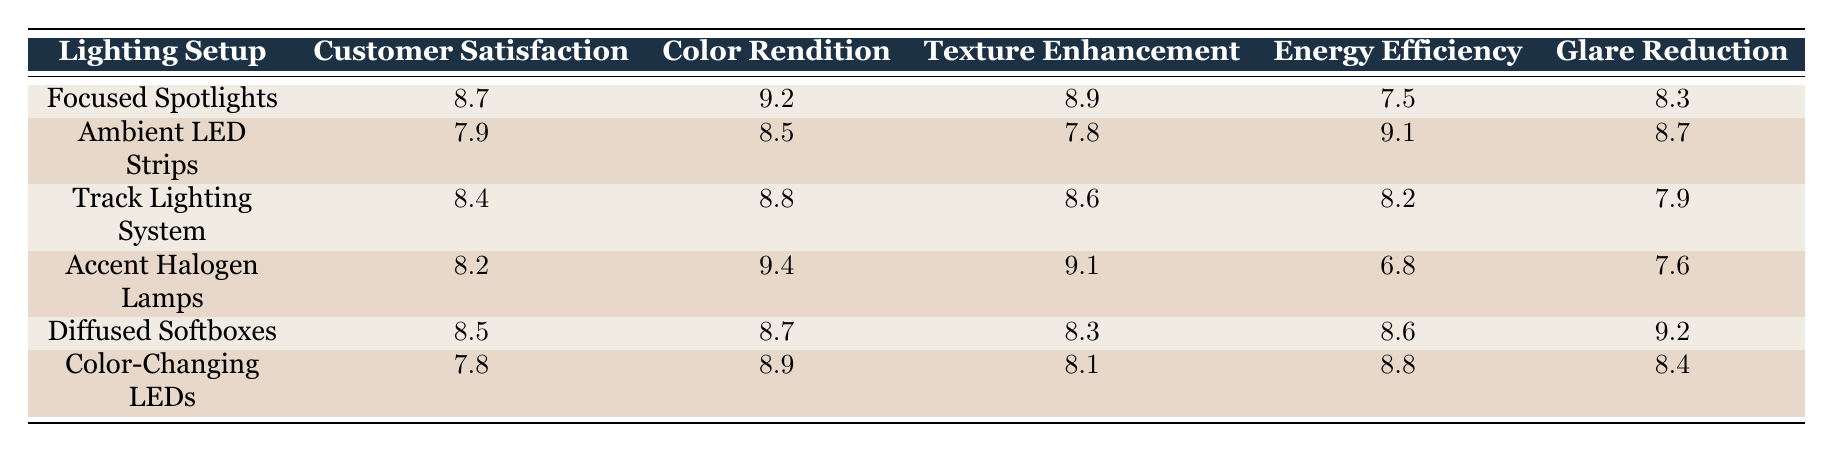What is the customer satisfaction rating for Focused Spotlights? The customer satisfaction rating for Focused Spotlights is listed directly in the table under the customer satisfaction column, which shows a value of 8.7.
Answer: 8.7 Which lighting setup has the highest color rendition score? The table indicates that Accent Halogen Lamps has the highest color rendition score of 9.4, which is the maximum value listed in that column.
Answer: Accent Halogen Lamps What is the average customer satisfaction rating for all the lighting setups? To find the average, we sum the customer satisfaction ratings: (8.7 + 7.9 + 8.4 + 8.2 + 8.5 + 7.8) = 49.5. Then we divide by the number of setups, which is 6. Thus, 49.5/6 = 8.25.
Answer: 8.25 Is the energy efficiency of Diffused Softboxes higher than that of Accent Halogen Lamps? By comparing the energy efficiency values in the table, we see that Diffused Softboxes has a score of 8.6 while Accent Halogen Lamps has a score of 6.8. Since 8.6 is greater than 6.8, the statement is true.
Answer: Yes Which lighting setup has the best glare reduction score, and what is that score? The glare reduction scores are compared from the table, and it is clear that Diffused Softboxes has the highest glare reduction score of 9.2.
Answer: Diffused Softboxes, 9.2 What is the difference in texture enhancement scores between Focused Spotlights and Color-Changing LEDs? The texture enhancement for Focused Spotlights is 8.9 and for Color-Changing LEDs is 8.1. The difference is calculated by subtracting: 8.9 - 8.1 = 0.8.
Answer: 0.8 Do Ambient LED Strips have a higher customer satisfaction rating than Color-Changing LEDs? By checking the table, the rating for Ambient LED Strips is 7.9 and for Color-Changing LEDs it is 7.8. Since 7.9 is greater than 7.8, the answer is yes.
Answer: Yes What is the lowest energy efficiency rating among the lighting setups? The table reveals that Accent Halogen Lamps has the lowest energy efficiency rating at 6.8 when comparing all the entries under that column.
Answer: Accent Halogen Lamps, 6.8 